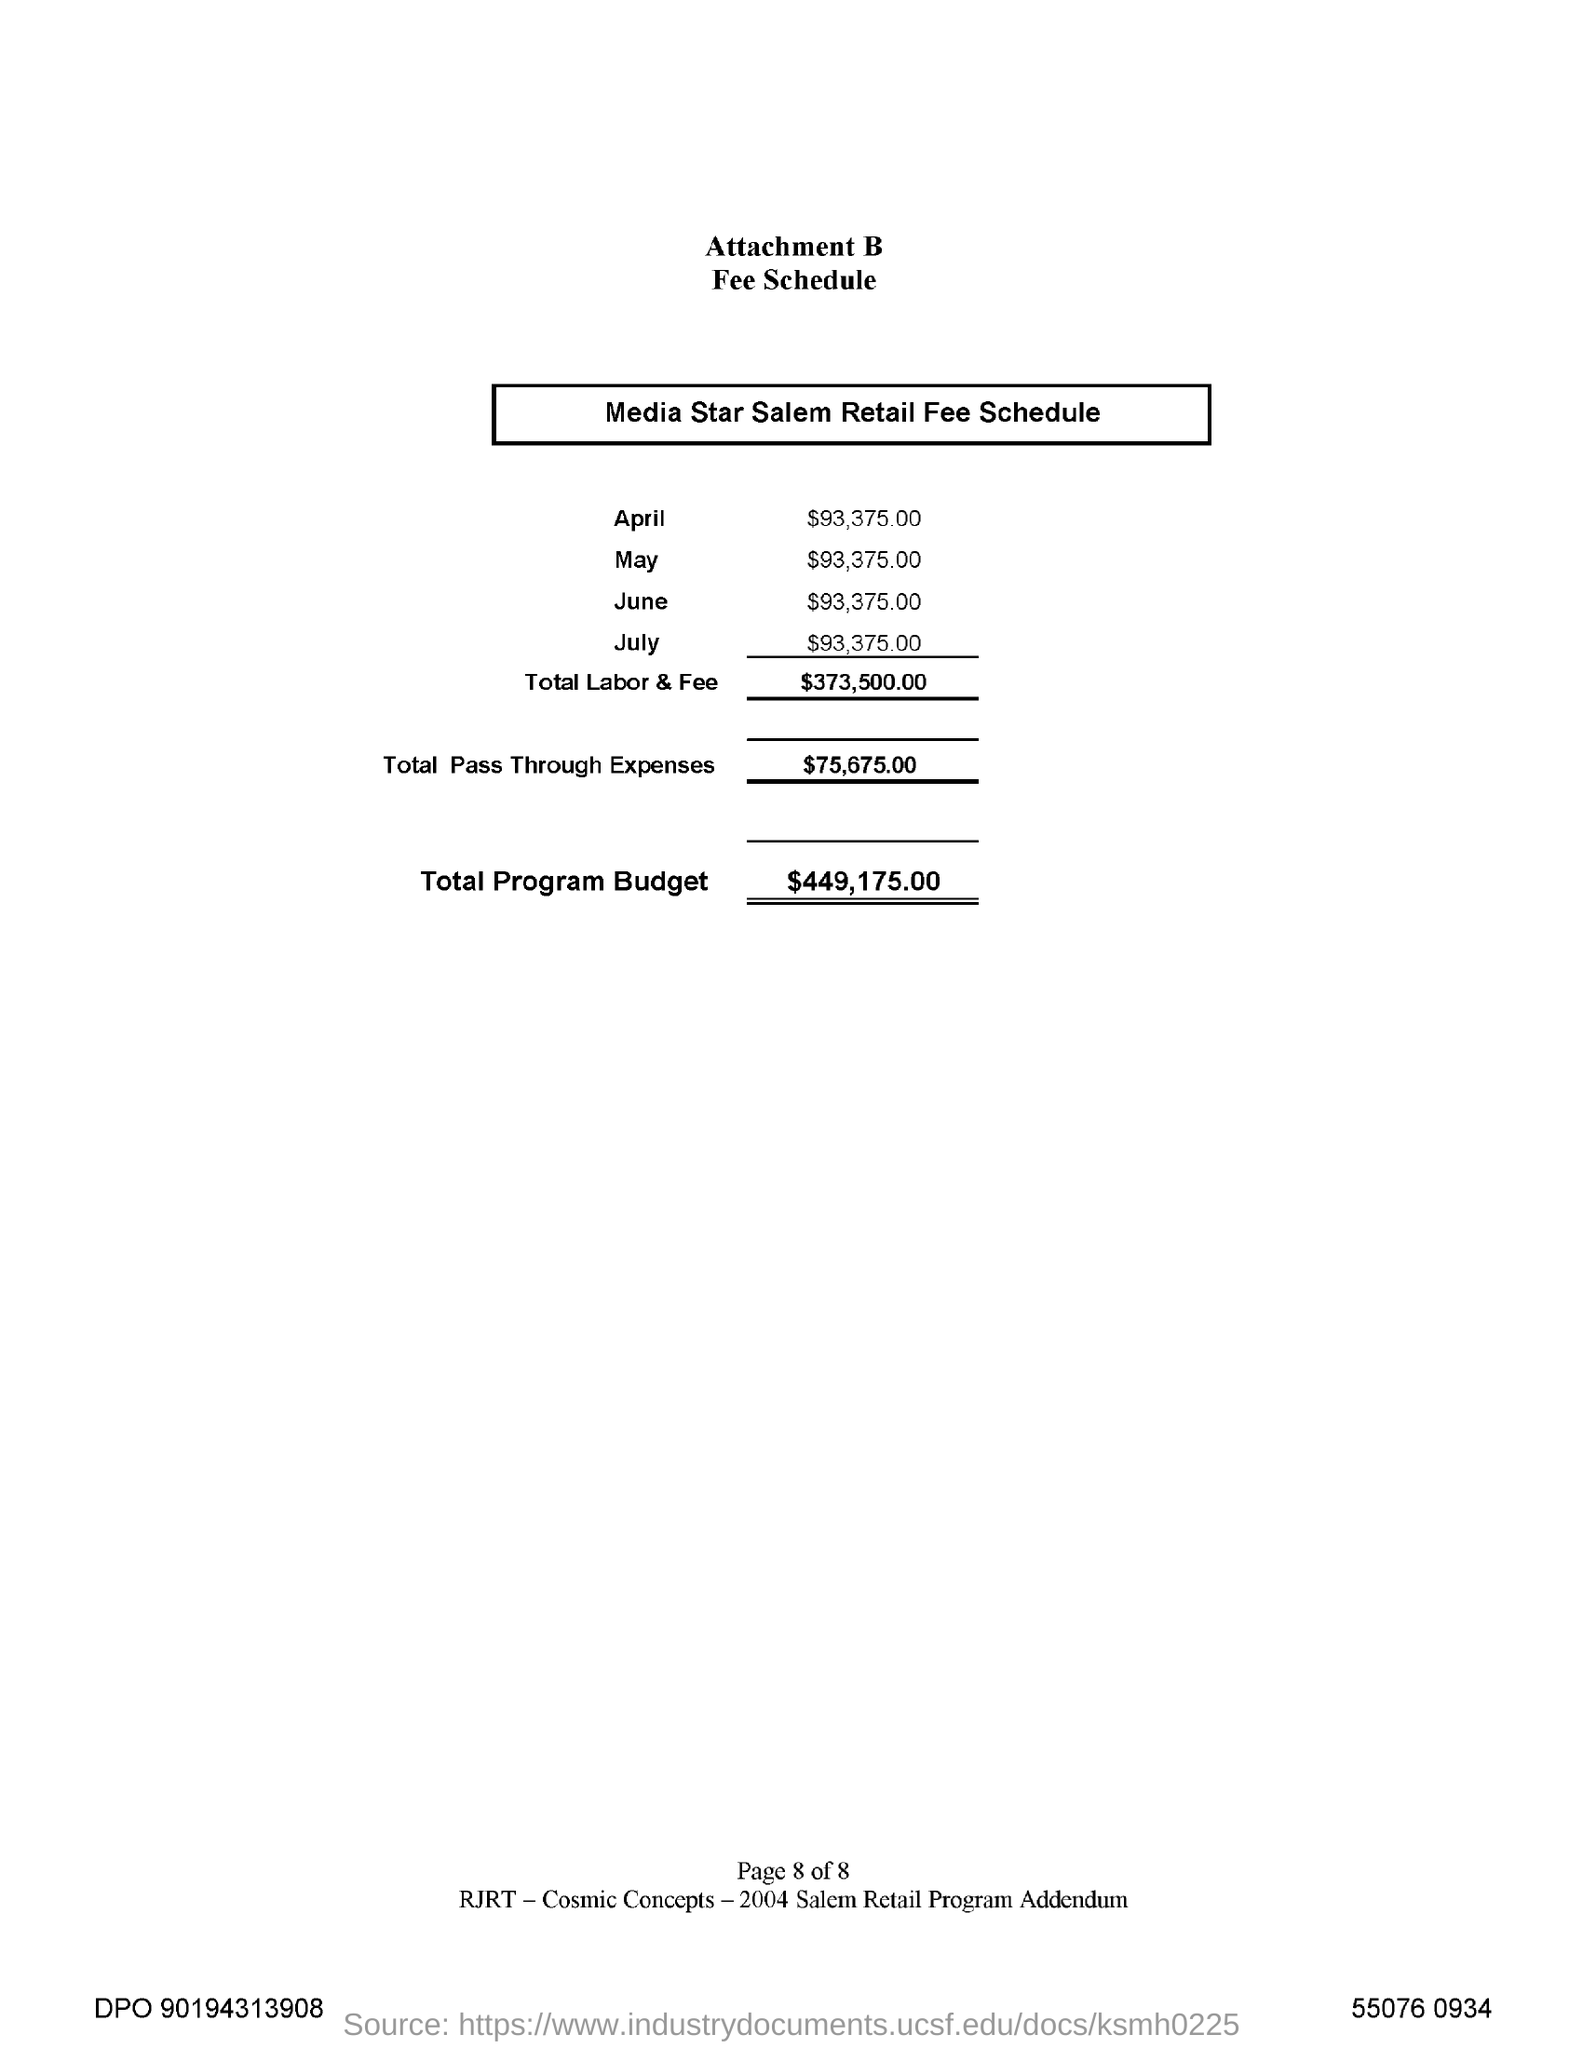What is the Total Labor & Fee?
Give a very brief answer. $373,500.00. What is the Total Program Budget?
Make the answer very short. $449,175.00. 